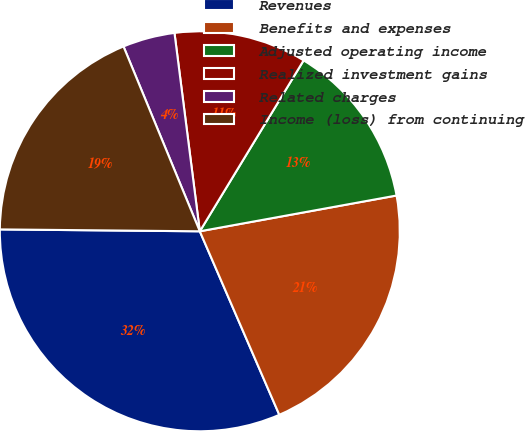Convert chart to OTSL. <chart><loc_0><loc_0><loc_500><loc_500><pie_chart><fcel>Revenues<fcel>Benefits and expenses<fcel>Adjusted operating income<fcel>Realized investment gains<fcel>Related charges<fcel>Income (loss) from continuing<nl><fcel>31.66%<fcel>21.36%<fcel>13.45%<fcel>10.71%<fcel>4.21%<fcel>18.62%<nl></chart> 